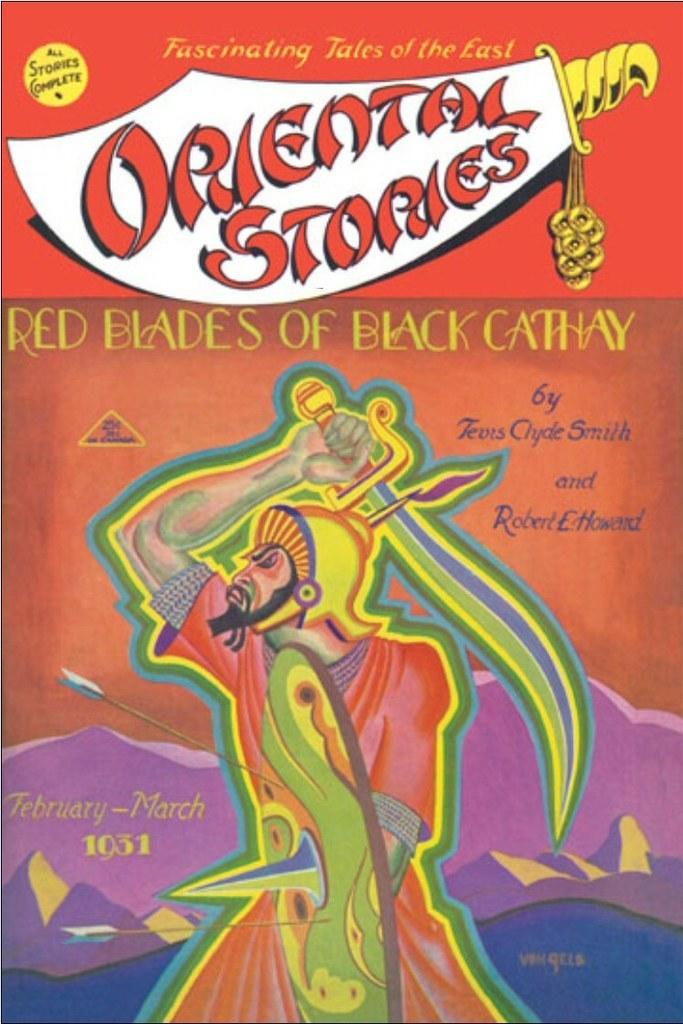In one or two sentences, can you explain what this image depicts? In this picture, we see the poster of the man holding a sword. We even see some text written on the poster. This poster is in red, brown, pink and white color. 